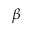<formula> <loc_0><loc_0><loc_500><loc_500>\beta</formula> 